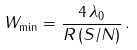<formula> <loc_0><loc_0><loc_500><loc_500>W _ { \min } = \frac { 4 \, \lambda _ { 0 } } { R \, ( S / N ) } \, .</formula> 